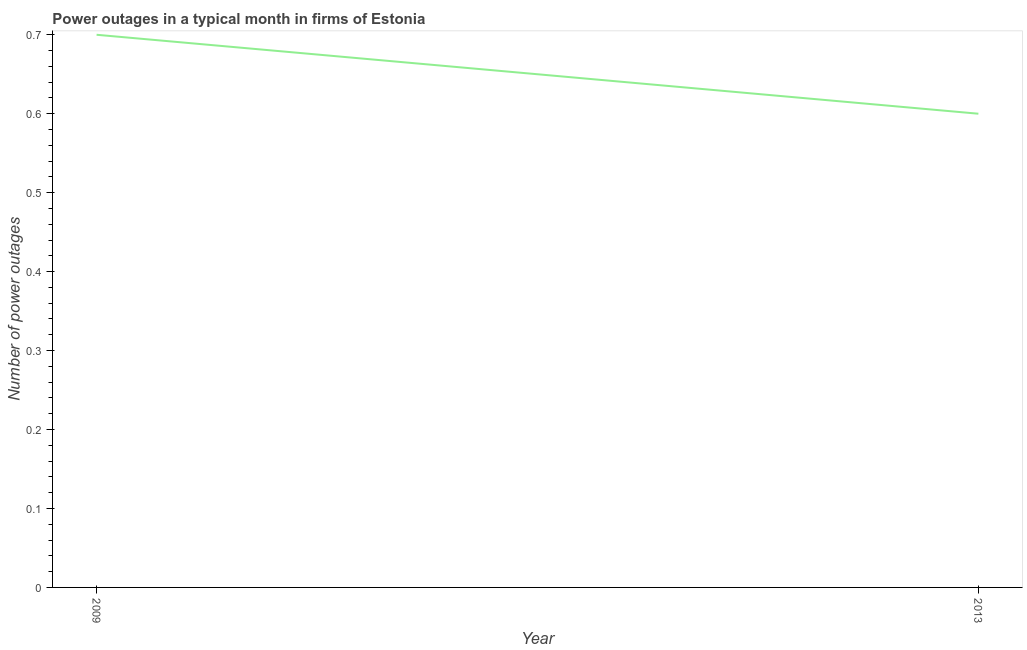Across all years, what is the maximum number of power outages?
Keep it short and to the point. 0.7. Across all years, what is the minimum number of power outages?
Offer a terse response. 0.6. In which year was the number of power outages minimum?
Offer a terse response. 2013. What is the sum of the number of power outages?
Your response must be concise. 1.3. What is the difference between the number of power outages in 2009 and 2013?
Provide a short and direct response. 0.1. What is the average number of power outages per year?
Your answer should be very brief. 0.65. What is the median number of power outages?
Give a very brief answer. 0.65. In how many years, is the number of power outages greater than 0.48000000000000004 ?
Your answer should be very brief. 2. What is the ratio of the number of power outages in 2009 to that in 2013?
Give a very brief answer. 1.17. Is the number of power outages in 2009 less than that in 2013?
Provide a short and direct response. No. Does the number of power outages monotonically increase over the years?
Your answer should be very brief. No. How many lines are there?
Give a very brief answer. 1. How many years are there in the graph?
Offer a very short reply. 2. Are the values on the major ticks of Y-axis written in scientific E-notation?
Ensure brevity in your answer.  No. Does the graph contain any zero values?
Your answer should be compact. No. What is the title of the graph?
Offer a terse response. Power outages in a typical month in firms of Estonia. What is the label or title of the Y-axis?
Provide a succinct answer. Number of power outages. What is the Number of power outages of 2009?
Your answer should be compact. 0.7. What is the Number of power outages in 2013?
Your answer should be compact. 0.6. What is the difference between the Number of power outages in 2009 and 2013?
Your answer should be compact. 0.1. What is the ratio of the Number of power outages in 2009 to that in 2013?
Offer a terse response. 1.17. 